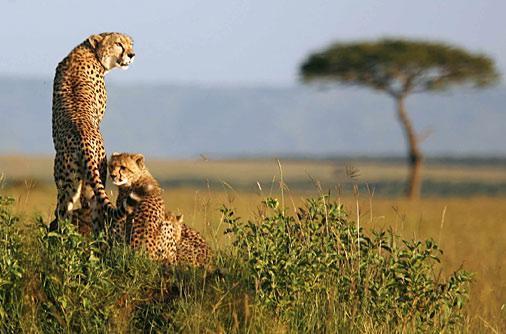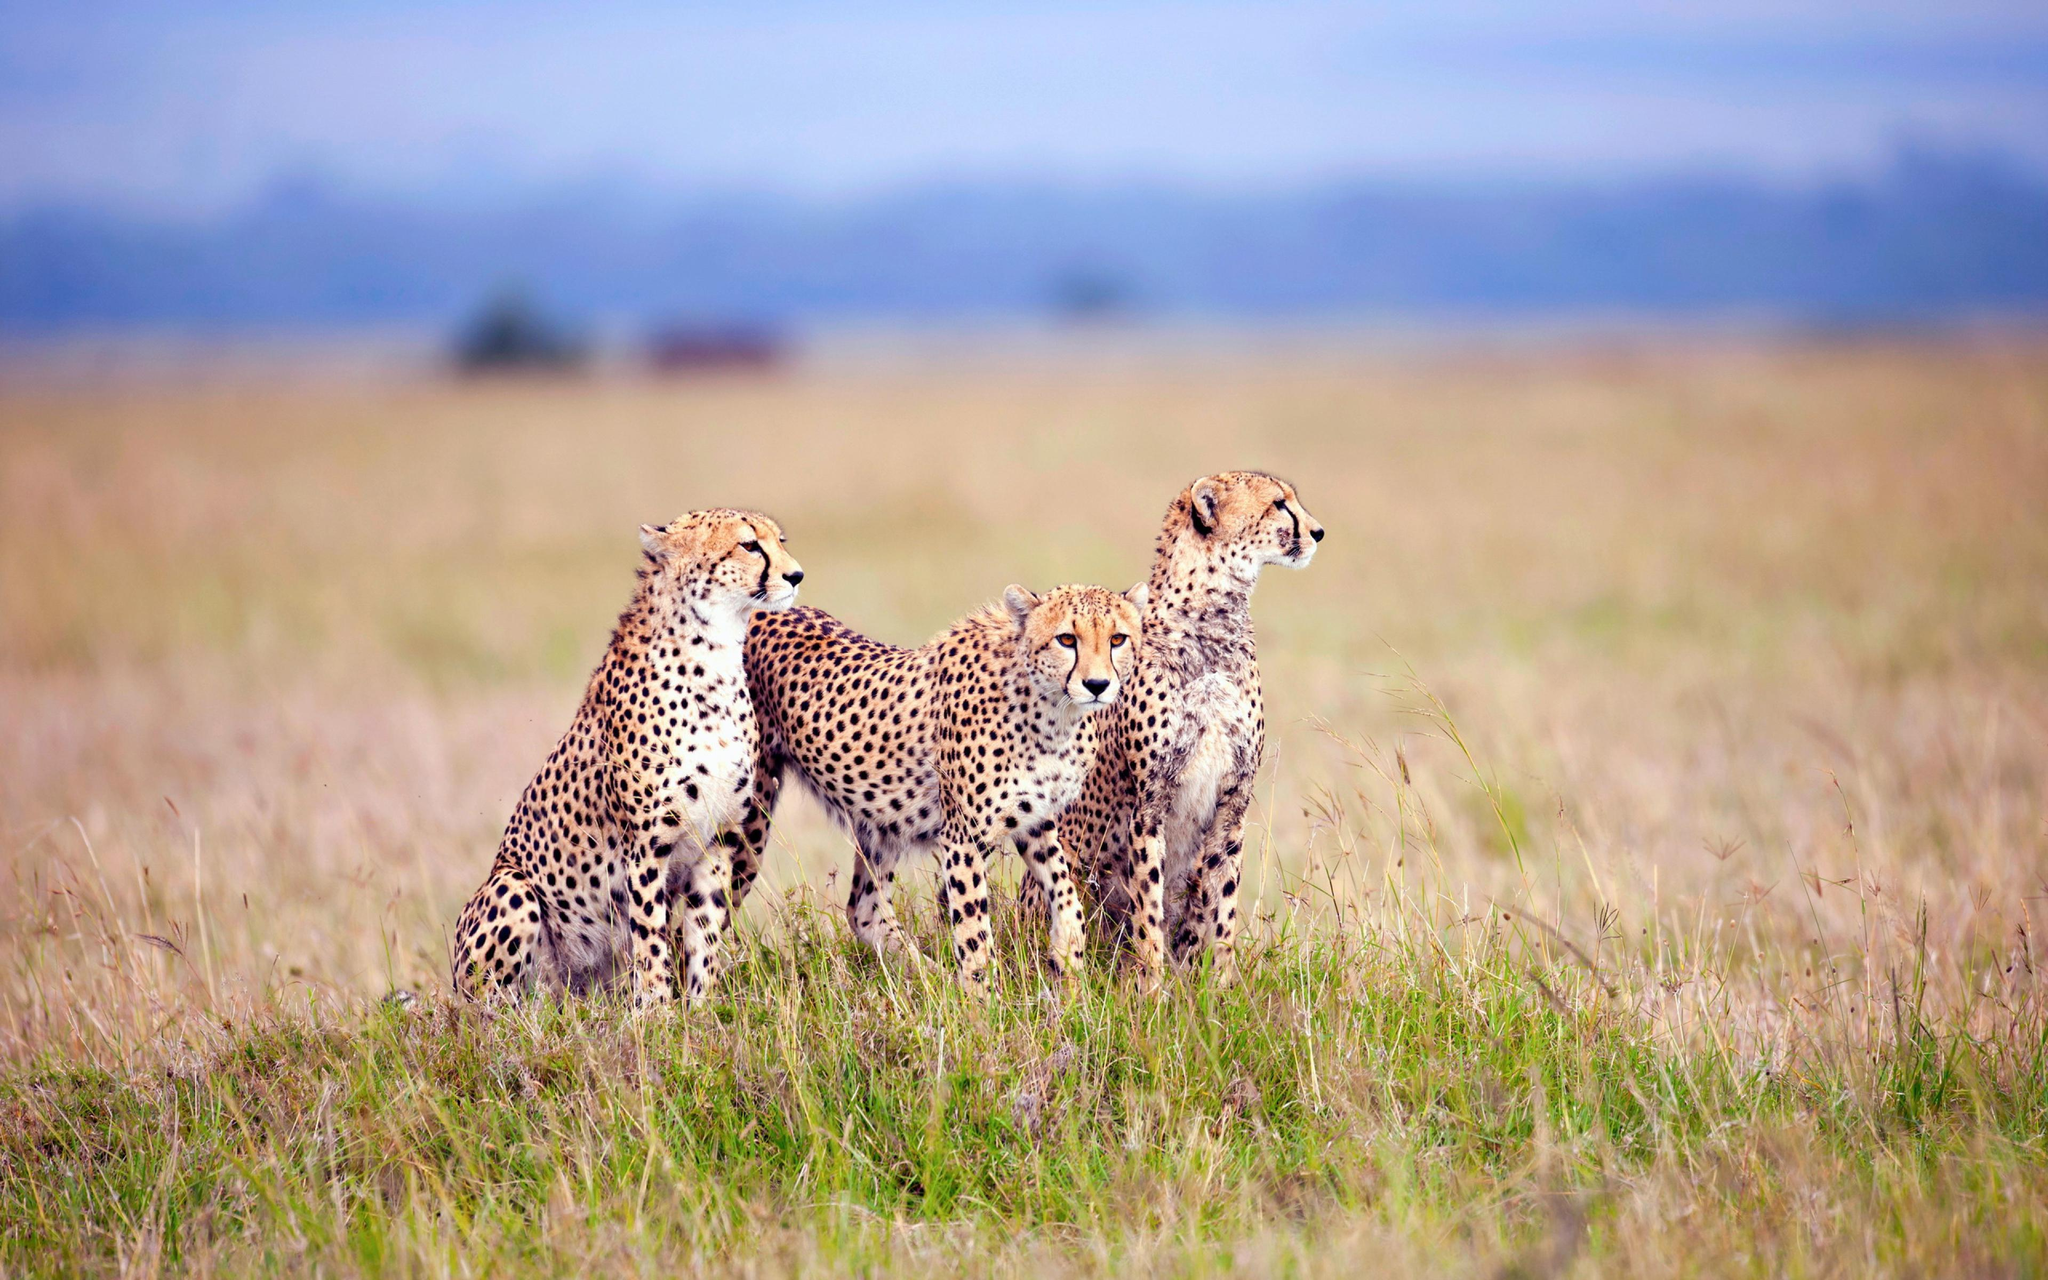The first image is the image on the left, the second image is the image on the right. For the images displayed, is the sentence "The right image contains exactly one cheetah." factually correct? Answer yes or no. No. The first image is the image on the left, the second image is the image on the right. Evaluate the accuracy of this statement regarding the images: "The left image contains exactly three cheetahs, and the right image includes an adult cheetah with its back to the camera and its head turned sharply to gaze right.". Is it true? Answer yes or no. No. 